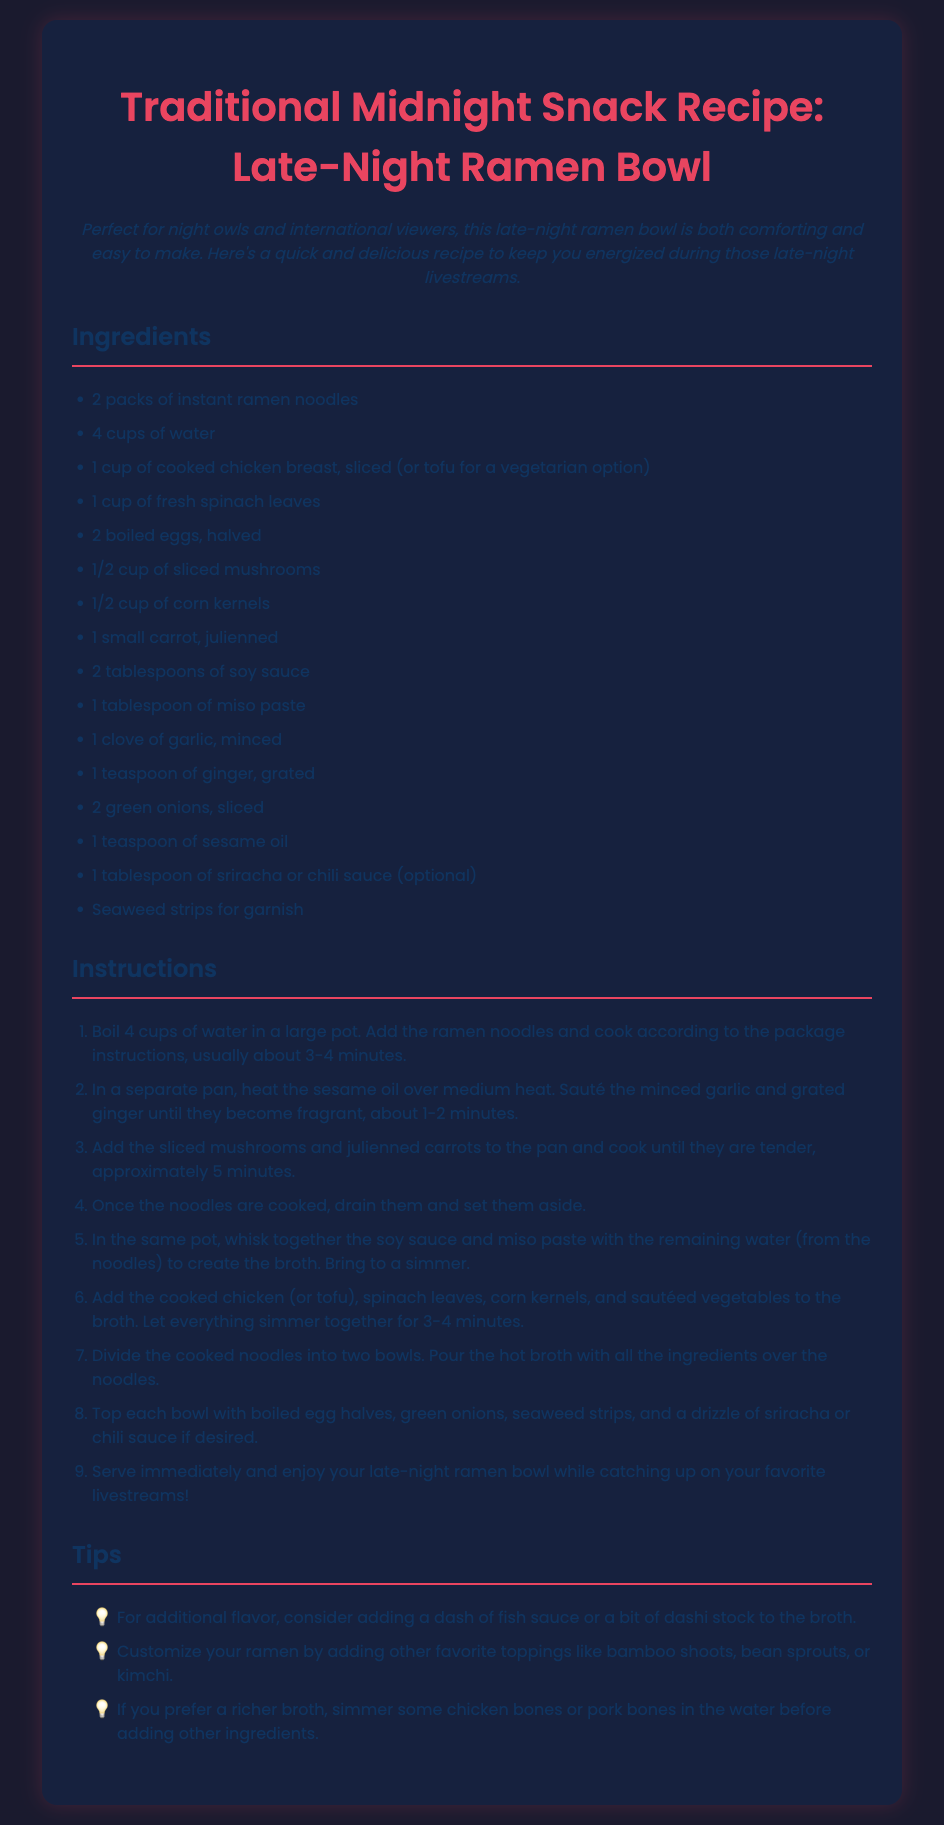what are the two options for protein in the ramen bowl? The recipe offers cooked chicken breast and tofu as protein options.
Answer: chicken breast, tofu how many cups of water are needed? The recipe states that 4 cups of water are needed.
Answer: 4 cups how long does it take to cook the noodles? According to the document, it's typically about 3-4 minutes to cook the ramen noodles.
Answer: 3-4 minutes what should be added for garnish? The document specifies seaweed strips as a garnish.
Answer: seaweed strips what is the total number of ingredients listed? The total number of distinct ingredients mentioned in the recipe card is 15.
Answer: 15 what ingredient adds a spicy kick if desired? Sriracha or chili sauce is mentioned as an optional ingredient for spice.
Answer: sriracha which ingredient is optional for enhancing the broth flavor? Fish sauce or dashi stock is suggested as an optional addition for flavor.
Answer: fish sauce in which step are the eggs added? The boiled egg halves are added in step 8 of the instructions.
Answer: step 8 what type of oil is used in the recipe? The recipe calls for sesame oil in the cooking process.
Answer: sesame oil 